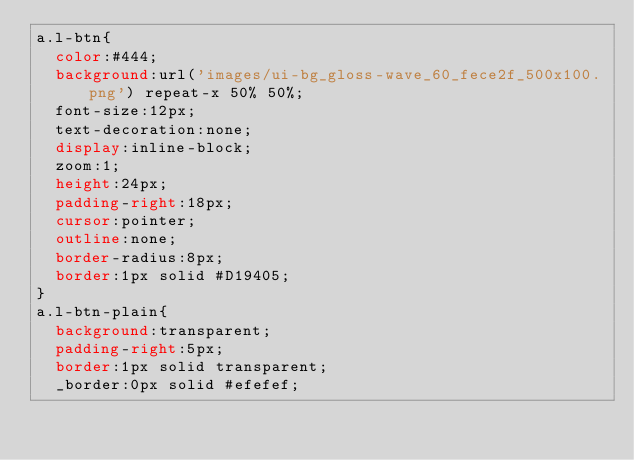Convert code to text. <code><loc_0><loc_0><loc_500><loc_500><_CSS_>a.l-btn{
	color:#444;
	background:url('images/ui-bg_gloss-wave_60_fece2f_500x100.png') repeat-x 50% 50%;
	font-size:12px;
	text-decoration:none;
	display:inline-block;
	zoom:1;
	height:24px;
	padding-right:18px;
	cursor:pointer;
	outline:none;
	border-radius:8px;
	border:1px solid #D19405;
}
a.l-btn-plain{
	background:transparent;
	padding-right:5px;
	border:1px solid transparent;
	_border:0px solid #efefef;</code> 